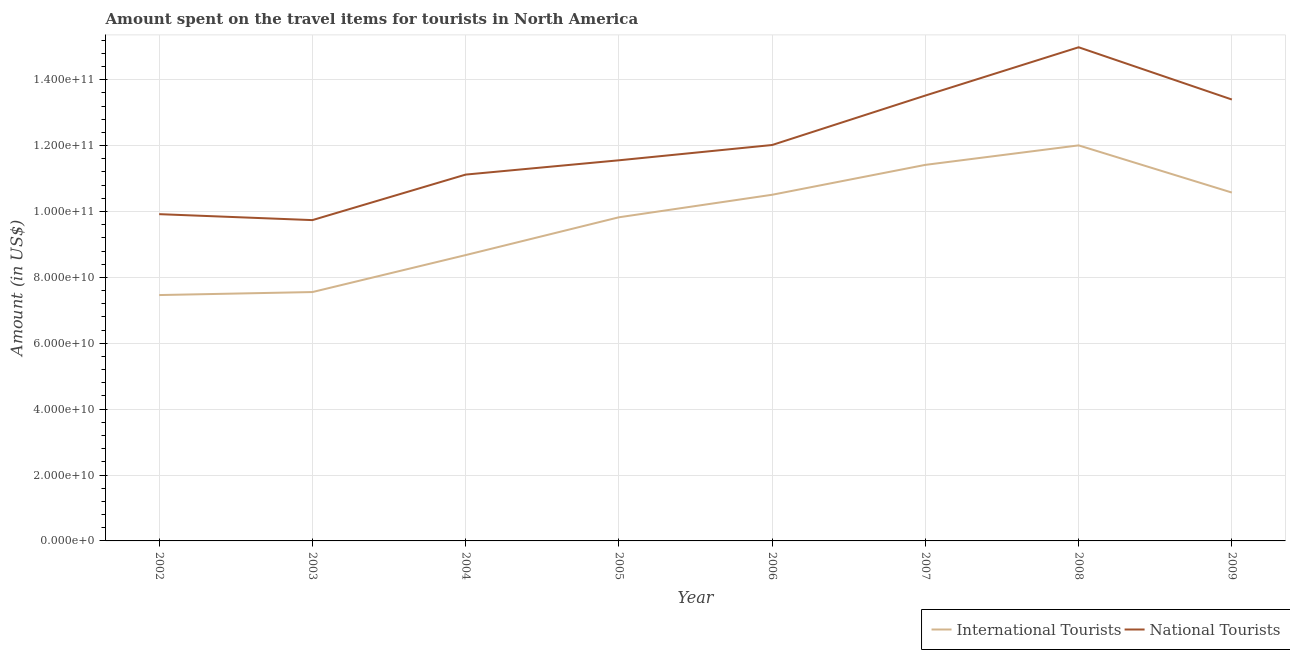What is the amount spent on travel items of national tourists in 2006?
Your response must be concise. 1.20e+11. Across all years, what is the maximum amount spent on travel items of national tourists?
Your answer should be compact. 1.50e+11. Across all years, what is the minimum amount spent on travel items of national tourists?
Your response must be concise. 9.74e+1. In which year was the amount spent on travel items of international tourists minimum?
Keep it short and to the point. 2002. What is the total amount spent on travel items of international tourists in the graph?
Offer a terse response. 7.80e+11. What is the difference between the amount spent on travel items of national tourists in 2003 and that in 2009?
Give a very brief answer. -3.66e+1. What is the difference between the amount spent on travel items of national tourists in 2004 and the amount spent on travel items of international tourists in 2005?
Keep it short and to the point. 1.30e+1. What is the average amount spent on travel items of international tourists per year?
Provide a short and direct response. 9.75e+1. In the year 2009, what is the difference between the amount spent on travel items of national tourists and amount spent on travel items of international tourists?
Your answer should be compact. 2.82e+1. What is the ratio of the amount spent on travel items of international tourists in 2004 to that in 2008?
Provide a succinct answer. 0.72. Is the amount spent on travel items of international tourists in 2006 less than that in 2009?
Keep it short and to the point. Yes. What is the difference between the highest and the second highest amount spent on travel items of international tourists?
Make the answer very short. 5.92e+09. What is the difference between the highest and the lowest amount spent on travel items of national tourists?
Make the answer very short. 5.25e+1. Is the sum of the amount spent on travel items of national tourists in 2003 and 2007 greater than the maximum amount spent on travel items of international tourists across all years?
Give a very brief answer. Yes. Is the amount spent on travel items of national tourists strictly greater than the amount spent on travel items of international tourists over the years?
Your answer should be very brief. Yes. Is the amount spent on travel items of national tourists strictly less than the amount spent on travel items of international tourists over the years?
Ensure brevity in your answer.  No. How many lines are there?
Make the answer very short. 2. How many years are there in the graph?
Provide a succinct answer. 8. Are the values on the major ticks of Y-axis written in scientific E-notation?
Keep it short and to the point. Yes. Does the graph contain any zero values?
Your response must be concise. No. Where does the legend appear in the graph?
Provide a succinct answer. Bottom right. What is the title of the graph?
Provide a succinct answer. Amount spent on the travel items for tourists in North America. Does "Birth rate" appear as one of the legend labels in the graph?
Give a very brief answer. No. What is the label or title of the Y-axis?
Provide a succinct answer. Amount (in US$). What is the Amount (in US$) of International Tourists in 2002?
Ensure brevity in your answer.  7.46e+1. What is the Amount (in US$) of National Tourists in 2002?
Provide a short and direct response. 9.92e+1. What is the Amount (in US$) in International Tourists in 2003?
Your response must be concise. 7.56e+1. What is the Amount (in US$) in National Tourists in 2003?
Offer a very short reply. 9.74e+1. What is the Amount (in US$) of International Tourists in 2004?
Your response must be concise. 8.68e+1. What is the Amount (in US$) in National Tourists in 2004?
Offer a very short reply. 1.11e+11. What is the Amount (in US$) of International Tourists in 2005?
Your answer should be compact. 9.82e+1. What is the Amount (in US$) of National Tourists in 2005?
Make the answer very short. 1.16e+11. What is the Amount (in US$) of International Tourists in 2006?
Your response must be concise. 1.05e+11. What is the Amount (in US$) in National Tourists in 2006?
Offer a very short reply. 1.20e+11. What is the Amount (in US$) in International Tourists in 2007?
Offer a terse response. 1.14e+11. What is the Amount (in US$) of National Tourists in 2007?
Provide a succinct answer. 1.35e+11. What is the Amount (in US$) in International Tourists in 2008?
Ensure brevity in your answer.  1.20e+11. What is the Amount (in US$) of National Tourists in 2008?
Your answer should be compact. 1.50e+11. What is the Amount (in US$) of International Tourists in 2009?
Provide a short and direct response. 1.06e+11. What is the Amount (in US$) in National Tourists in 2009?
Give a very brief answer. 1.34e+11. Across all years, what is the maximum Amount (in US$) in International Tourists?
Give a very brief answer. 1.20e+11. Across all years, what is the maximum Amount (in US$) in National Tourists?
Provide a short and direct response. 1.50e+11. Across all years, what is the minimum Amount (in US$) of International Tourists?
Your answer should be compact. 7.46e+1. Across all years, what is the minimum Amount (in US$) of National Tourists?
Offer a very short reply. 9.74e+1. What is the total Amount (in US$) in International Tourists in the graph?
Your response must be concise. 7.80e+11. What is the total Amount (in US$) of National Tourists in the graph?
Your answer should be compact. 9.63e+11. What is the difference between the Amount (in US$) of International Tourists in 2002 and that in 2003?
Offer a very short reply. -9.15e+08. What is the difference between the Amount (in US$) in National Tourists in 2002 and that in 2003?
Your answer should be compact. 1.81e+09. What is the difference between the Amount (in US$) in International Tourists in 2002 and that in 2004?
Make the answer very short. -1.21e+1. What is the difference between the Amount (in US$) of National Tourists in 2002 and that in 2004?
Give a very brief answer. -1.20e+1. What is the difference between the Amount (in US$) in International Tourists in 2002 and that in 2005?
Your answer should be very brief. -2.36e+1. What is the difference between the Amount (in US$) in National Tourists in 2002 and that in 2005?
Your answer should be very brief. -1.63e+1. What is the difference between the Amount (in US$) in International Tourists in 2002 and that in 2006?
Make the answer very short. -3.05e+1. What is the difference between the Amount (in US$) of National Tourists in 2002 and that in 2006?
Your response must be concise. -2.10e+1. What is the difference between the Amount (in US$) of International Tourists in 2002 and that in 2007?
Provide a short and direct response. -3.95e+1. What is the difference between the Amount (in US$) of National Tourists in 2002 and that in 2007?
Offer a very short reply. -3.60e+1. What is the difference between the Amount (in US$) in International Tourists in 2002 and that in 2008?
Offer a terse response. -4.54e+1. What is the difference between the Amount (in US$) in National Tourists in 2002 and that in 2008?
Give a very brief answer. -5.07e+1. What is the difference between the Amount (in US$) in International Tourists in 2002 and that in 2009?
Make the answer very short. -3.11e+1. What is the difference between the Amount (in US$) of National Tourists in 2002 and that in 2009?
Give a very brief answer. -3.48e+1. What is the difference between the Amount (in US$) of International Tourists in 2003 and that in 2004?
Give a very brief answer. -1.12e+1. What is the difference between the Amount (in US$) of National Tourists in 2003 and that in 2004?
Offer a very short reply. -1.38e+1. What is the difference between the Amount (in US$) of International Tourists in 2003 and that in 2005?
Your answer should be very brief. -2.27e+1. What is the difference between the Amount (in US$) in National Tourists in 2003 and that in 2005?
Offer a terse response. -1.82e+1. What is the difference between the Amount (in US$) in International Tourists in 2003 and that in 2006?
Offer a terse response. -2.95e+1. What is the difference between the Amount (in US$) of National Tourists in 2003 and that in 2006?
Provide a succinct answer. -2.28e+1. What is the difference between the Amount (in US$) of International Tourists in 2003 and that in 2007?
Provide a succinct answer. -3.86e+1. What is the difference between the Amount (in US$) of National Tourists in 2003 and that in 2007?
Keep it short and to the point. -3.78e+1. What is the difference between the Amount (in US$) in International Tourists in 2003 and that in 2008?
Provide a succinct answer. -4.45e+1. What is the difference between the Amount (in US$) in National Tourists in 2003 and that in 2008?
Your response must be concise. -5.25e+1. What is the difference between the Amount (in US$) in International Tourists in 2003 and that in 2009?
Provide a short and direct response. -3.02e+1. What is the difference between the Amount (in US$) in National Tourists in 2003 and that in 2009?
Ensure brevity in your answer.  -3.66e+1. What is the difference between the Amount (in US$) of International Tourists in 2004 and that in 2005?
Give a very brief answer. -1.15e+1. What is the difference between the Amount (in US$) in National Tourists in 2004 and that in 2005?
Keep it short and to the point. -4.34e+09. What is the difference between the Amount (in US$) of International Tourists in 2004 and that in 2006?
Your answer should be compact. -1.83e+1. What is the difference between the Amount (in US$) in National Tourists in 2004 and that in 2006?
Offer a very short reply. -8.98e+09. What is the difference between the Amount (in US$) in International Tourists in 2004 and that in 2007?
Make the answer very short. -2.74e+1. What is the difference between the Amount (in US$) of National Tourists in 2004 and that in 2007?
Offer a very short reply. -2.40e+1. What is the difference between the Amount (in US$) of International Tourists in 2004 and that in 2008?
Make the answer very short. -3.33e+1. What is the difference between the Amount (in US$) in National Tourists in 2004 and that in 2008?
Your answer should be compact. -3.87e+1. What is the difference between the Amount (in US$) in International Tourists in 2004 and that in 2009?
Give a very brief answer. -1.90e+1. What is the difference between the Amount (in US$) of National Tourists in 2004 and that in 2009?
Keep it short and to the point. -2.28e+1. What is the difference between the Amount (in US$) in International Tourists in 2005 and that in 2006?
Your answer should be compact. -6.84e+09. What is the difference between the Amount (in US$) of National Tourists in 2005 and that in 2006?
Make the answer very short. -4.64e+09. What is the difference between the Amount (in US$) in International Tourists in 2005 and that in 2007?
Make the answer very short. -1.59e+1. What is the difference between the Amount (in US$) of National Tourists in 2005 and that in 2007?
Provide a short and direct response. -1.97e+1. What is the difference between the Amount (in US$) of International Tourists in 2005 and that in 2008?
Your response must be concise. -2.18e+1. What is the difference between the Amount (in US$) of National Tourists in 2005 and that in 2008?
Make the answer very short. -3.43e+1. What is the difference between the Amount (in US$) in International Tourists in 2005 and that in 2009?
Your response must be concise. -7.50e+09. What is the difference between the Amount (in US$) in National Tourists in 2005 and that in 2009?
Give a very brief answer. -1.84e+1. What is the difference between the Amount (in US$) in International Tourists in 2006 and that in 2007?
Your response must be concise. -9.08e+09. What is the difference between the Amount (in US$) in National Tourists in 2006 and that in 2007?
Offer a very short reply. -1.50e+1. What is the difference between the Amount (in US$) in International Tourists in 2006 and that in 2008?
Give a very brief answer. -1.50e+1. What is the difference between the Amount (in US$) of National Tourists in 2006 and that in 2008?
Your response must be concise. -2.97e+1. What is the difference between the Amount (in US$) of International Tourists in 2006 and that in 2009?
Offer a very short reply. -6.65e+08. What is the difference between the Amount (in US$) of National Tourists in 2006 and that in 2009?
Offer a terse response. -1.38e+1. What is the difference between the Amount (in US$) of International Tourists in 2007 and that in 2008?
Offer a very short reply. -5.92e+09. What is the difference between the Amount (in US$) in National Tourists in 2007 and that in 2008?
Ensure brevity in your answer.  -1.47e+1. What is the difference between the Amount (in US$) of International Tourists in 2007 and that in 2009?
Your response must be concise. 8.41e+09. What is the difference between the Amount (in US$) in National Tourists in 2007 and that in 2009?
Your answer should be compact. 1.21e+09. What is the difference between the Amount (in US$) in International Tourists in 2008 and that in 2009?
Ensure brevity in your answer.  1.43e+1. What is the difference between the Amount (in US$) of National Tourists in 2008 and that in 2009?
Keep it short and to the point. 1.59e+1. What is the difference between the Amount (in US$) of International Tourists in 2002 and the Amount (in US$) of National Tourists in 2003?
Your response must be concise. -2.28e+1. What is the difference between the Amount (in US$) in International Tourists in 2002 and the Amount (in US$) in National Tourists in 2004?
Offer a terse response. -3.66e+1. What is the difference between the Amount (in US$) in International Tourists in 2002 and the Amount (in US$) in National Tourists in 2005?
Make the answer very short. -4.09e+1. What is the difference between the Amount (in US$) of International Tourists in 2002 and the Amount (in US$) of National Tourists in 2006?
Your answer should be very brief. -4.56e+1. What is the difference between the Amount (in US$) in International Tourists in 2002 and the Amount (in US$) in National Tourists in 2007?
Your response must be concise. -6.06e+1. What is the difference between the Amount (in US$) in International Tourists in 2002 and the Amount (in US$) in National Tourists in 2008?
Ensure brevity in your answer.  -7.52e+1. What is the difference between the Amount (in US$) of International Tourists in 2002 and the Amount (in US$) of National Tourists in 2009?
Keep it short and to the point. -5.94e+1. What is the difference between the Amount (in US$) in International Tourists in 2003 and the Amount (in US$) in National Tourists in 2004?
Make the answer very short. -3.57e+1. What is the difference between the Amount (in US$) of International Tourists in 2003 and the Amount (in US$) of National Tourists in 2005?
Provide a succinct answer. -4.00e+1. What is the difference between the Amount (in US$) of International Tourists in 2003 and the Amount (in US$) of National Tourists in 2006?
Your answer should be very brief. -4.46e+1. What is the difference between the Amount (in US$) of International Tourists in 2003 and the Amount (in US$) of National Tourists in 2007?
Ensure brevity in your answer.  -5.97e+1. What is the difference between the Amount (in US$) of International Tourists in 2003 and the Amount (in US$) of National Tourists in 2008?
Offer a very short reply. -7.43e+1. What is the difference between the Amount (in US$) in International Tourists in 2003 and the Amount (in US$) in National Tourists in 2009?
Your response must be concise. -5.84e+1. What is the difference between the Amount (in US$) of International Tourists in 2004 and the Amount (in US$) of National Tourists in 2005?
Keep it short and to the point. -2.88e+1. What is the difference between the Amount (in US$) in International Tourists in 2004 and the Amount (in US$) in National Tourists in 2006?
Your answer should be compact. -3.34e+1. What is the difference between the Amount (in US$) of International Tourists in 2004 and the Amount (in US$) of National Tourists in 2007?
Offer a terse response. -4.84e+1. What is the difference between the Amount (in US$) of International Tourists in 2004 and the Amount (in US$) of National Tourists in 2008?
Keep it short and to the point. -6.31e+1. What is the difference between the Amount (in US$) of International Tourists in 2004 and the Amount (in US$) of National Tourists in 2009?
Offer a very short reply. -4.72e+1. What is the difference between the Amount (in US$) in International Tourists in 2005 and the Amount (in US$) in National Tourists in 2006?
Keep it short and to the point. -2.19e+1. What is the difference between the Amount (in US$) in International Tourists in 2005 and the Amount (in US$) in National Tourists in 2007?
Keep it short and to the point. -3.70e+1. What is the difference between the Amount (in US$) in International Tourists in 2005 and the Amount (in US$) in National Tourists in 2008?
Provide a succinct answer. -5.16e+1. What is the difference between the Amount (in US$) of International Tourists in 2005 and the Amount (in US$) of National Tourists in 2009?
Your answer should be compact. -3.57e+1. What is the difference between the Amount (in US$) of International Tourists in 2006 and the Amount (in US$) of National Tourists in 2007?
Provide a short and direct response. -3.01e+1. What is the difference between the Amount (in US$) in International Tourists in 2006 and the Amount (in US$) in National Tourists in 2008?
Provide a succinct answer. -4.48e+1. What is the difference between the Amount (in US$) in International Tourists in 2006 and the Amount (in US$) in National Tourists in 2009?
Ensure brevity in your answer.  -2.89e+1. What is the difference between the Amount (in US$) in International Tourists in 2007 and the Amount (in US$) in National Tourists in 2008?
Keep it short and to the point. -3.57e+1. What is the difference between the Amount (in US$) of International Tourists in 2007 and the Amount (in US$) of National Tourists in 2009?
Your answer should be compact. -1.98e+1. What is the difference between the Amount (in US$) of International Tourists in 2008 and the Amount (in US$) of National Tourists in 2009?
Your answer should be very brief. -1.39e+1. What is the average Amount (in US$) of International Tourists per year?
Your answer should be compact. 9.75e+1. What is the average Amount (in US$) of National Tourists per year?
Offer a terse response. 1.20e+11. In the year 2002, what is the difference between the Amount (in US$) in International Tourists and Amount (in US$) in National Tourists?
Your response must be concise. -2.46e+1. In the year 2003, what is the difference between the Amount (in US$) of International Tourists and Amount (in US$) of National Tourists?
Provide a succinct answer. -2.18e+1. In the year 2004, what is the difference between the Amount (in US$) of International Tourists and Amount (in US$) of National Tourists?
Offer a very short reply. -2.44e+1. In the year 2005, what is the difference between the Amount (in US$) in International Tourists and Amount (in US$) in National Tourists?
Give a very brief answer. -1.73e+1. In the year 2006, what is the difference between the Amount (in US$) in International Tourists and Amount (in US$) in National Tourists?
Provide a short and direct response. -1.51e+1. In the year 2007, what is the difference between the Amount (in US$) in International Tourists and Amount (in US$) in National Tourists?
Provide a short and direct response. -2.10e+1. In the year 2008, what is the difference between the Amount (in US$) in International Tourists and Amount (in US$) in National Tourists?
Provide a short and direct response. -2.98e+1. In the year 2009, what is the difference between the Amount (in US$) of International Tourists and Amount (in US$) of National Tourists?
Offer a terse response. -2.82e+1. What is the ratio of the Amount (in US$) in International Tourists in 2002 to that in 2003?
Offer a very short reply. 0.99. What is the ratio of the Amount (in US$) of National Tourists in 2002 to that in 2003?
Provide a short and direct response. 1.02. What is the ratio of the Amount (in US$) in International Tourists in 2002 to that in 2004?
Offer a very short reply. 0.86. What is the ratio of the Amount (in US$) in National Tourists in 2002 to that in 2004?
Offer a very short reply. 0.89. What is the ratio of the Amount (in US$) of International Tourists in 2002 to that in 2005?
Your response must be concise. 0.76. What is the ratio of the Amount (in US$) in National Tourists in 2002 to that in 2005?
Offer a terse response. 0.86. What is the ratio of the Amount (in US$) of International Tourists in 2002 to that in 2006?
Make the answer very short. 0.71. What is the ratio of the Amount (in US$) of National Tourists in 2002 to that in 2006?
Make the answer very short. 0.83. What is the ratio of the Amount (in US$) in International Tourists in 2002 to that in 2007?
Ensure brevity in your answer.  0.65. What is the ratio of the Amount (in US$) of National Tourists in 2002 to that in 2007?
Offer a very short reply. 0.73. What is the ratio of the Amount (in US$) in International Tourists in 2002 to that in 2008?
Ensure brevity in your answer.  0.62. What is the ratio of the Amount (in US$) of National Tourists in 2002 to that in 2008?
Provide a short and direct response. 0.66. What is the ratio of the Amount (in US$) of International Tourists in 2002 to that in 2009?
Your response must be concise. 0.71. What is the ratio of the Amount (in US$) of National Tourists in 2002 to that in 2009?
Provide a succinct answer. 0.74. What is the ratio of the Amount (in US$) of International Tourists in 2003 to that in 2004?
Your response must be concise. 0.87. What is the ratio of the Amount (in US$) of National Tourists in 2003 to that in 2004?
Ensure brevity in your answer.  0.88. What is the ratio of the Amount (in US$) in International Tourists in 2003 to that in 2005?
Keep it short and to the point. 0.77. What is the ratio of the Amount (in US$) in National Tourists in 2003 to that in 2005?
Provide a short and direct response. 0.84. What is the ratio of the Amount (in US$) in International Tourists in 2003 to that in 2006?
Make the answer very short. 0.72. What is the ratio of the Amount (in US$) in National Tourists in 2003 to that in 2006?
Make the answer very short. 0.81. What is the ratio of the Amount (in US$) of International Tourists in 2003 to that in 2007?
Provide a succinct answer. 0.66. What is the ratio of the Amount (in US$) of National Tourists in 2003 to that in 2007?
Provide a succinct answer. 0.72. What is the ratio of the Amount (in US$) in International Tourists in 2003 to that in 2008?
Provide a short and direct response. 0.63. What is the ratio of the Amount (in US$) of National Tourists in 2003 to that in 2008?
Provide a short and direct response. 0.65. What is the ratio of the Amount (in US$) of International Tourists in 2003 to that in 2009?
Provide a succinct answer. 0.71. What is the ratio of the Amount (in US$) in National Tourists in 2003 to that in 2009?
Ensure brevity in your answer.  0.73. What is the ratio of the Amount (in US$) in International Tourists in 2004 to that in 2005?
Provide a succinct answer. 0.88. What is the ratio of the Amount (in US$) in National Tourists in 2004 to that in 2005?
Your response must be concise. 0.96. What is the ratio of the Amount (in US$) of International Tourists in 2004 to that in 2006?
Keep it short and to the point. 0.83. What is the ratio of the Amount (in US$) of National Tourists in 2004 to that in 2006?
Give a very brief answer. 0.93. What is the ratio of the Amount (in US$) of International Tourists in 2004 to that in 2007?
Make the answer very short. 0.76. What is the ratio of the Amount (in US$) of National Tourists in 2004 to that in 2007?
Provide a succinct answer. 0.82. What is the ratio of the Amount (in US$) in International Tourists in 2004 to that in 2008?
Provide a succinct answer. 0.72. What is the ratio of the Amount (in US$) of National Tourists in 2004 to that in 2008?
Your response must be concise. 0.74. What is the ratio of the Amount (in US$) in International Tourists in 2004 to that in 2009?
Your response must be concise. 0.82. What is the ratio of the Amount (in US$) in National Tourists in 2004 to that in 2009?
Ensure brevity in your answer.  0.83. What is the ratio of the Amount (in US$) in International Tourists in 2005 to that in 2006?
Offer a terse response. 0.93. What is the ratio of the Amount (in US$) of National Tourists in 2005 to that in 2006?
Your answer should be very brief. 0.96. What is the ratio of the Amount (in US$) in International Tourists in 2005 to that in 2007?
Provide a succinct answer. 0.86. What is the ratio of the Amount (in US$) in National Tourists in 2005 to that in 2007?
Provide a short and direct response. 0.85. What is the ratio of the Amount (in US$) in International Tourists in 2005 to that in 2008?
Offer a very short reply. 0.82. What is the ratio of the Amount (in US$) of National Tourists in 2005 to that in 2008?
Offer a terse response. 0.77. What is the ratio of the Amount (in US$) in International Tourists in 2005 to that in 2009?
Offer a very short reply. 0.93. What is the ratio of the Amount (in US$) in National Tourists in 2005 to that in 2009?
Ensure brevity in your answer.  0.86. What is the ratio of the Amount (in US$) in International Tourists in 2006 to that in 2007?
Your answer should be compact. 0.92. What is the ratio of the Amount (in US$) in International Tourists in 2006 to that in 2008?
Give a very brief answer. 0.88. What is the ratio of the Amount (in US$) in National Tourists in 2006 to that in 2008?
Provide a short and direct response. 0.8. What is the ratio of the Amount (in US$) in National Tourists in 2006 to that in 2009?
Your answer should be compact. 0.9. What is the ratio of the Amount (in US$) of International Tourists in 2007 to that in 2008?
Provide a succinct answer. 0.95. What is the ratio of the Amount (in US$) of National Tourists in 2007 to that in 2008?
Provide a succinct answer. 0.9. What is the ratio of the Amount (in US$) of International Tourists in 2007 to that in 2009?
Give a very brief answer. 1.08. What is the ratio of the Amount (in US$) in International Tourists in 2008 to that in 2009?
Give a very brief answer. 1.14. What is the ratio of the Amount (in US$) of National Tourists in 2008 to that in 2009?
Make the answer very short. 1.12. What is the difference between the highest and the second highest Amount (in US$) of International Tourists?
Make the answer very short. 5.92e+09. What is the difference between the highest and the second highest Amount (in US$) in National Tourists?
Make the answer very short. 1.47e+1. What is the difference between the highest and the lowest Amount (in US$) in International Tourists?
Provide a succinct answer. 4.54e+1. What is the difference between the highest and the lowest Amount (in US$) of National Tourists?
Your response must be concise. 5.25e+1. 